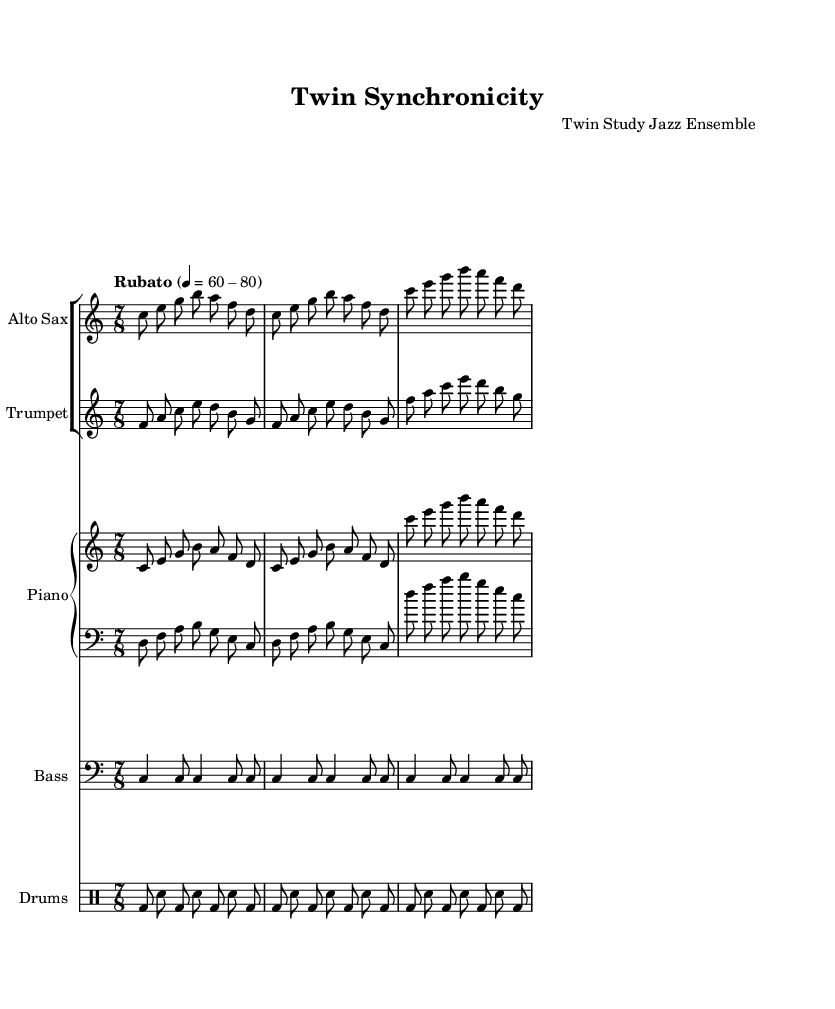What is the time signature of this music? The time signature is indicated at the beginning of the piece, where it is shown as 7/8. This indicates that there are seven beats in a measure and the eighth note gets one beat.
Answer: 7/8 What is the tempo marking of the composition? The tempo marking is found in the global section where it states "Rubato" with a range of quarter note beats of 60 to 80. "Rubato" suggests a flexible tempo, allowing for expressive performance.
Answer: Rubato 60-80 How many measures are there in the piano right-hand part? By examining the provided part for the piano right-hand, we notice that it contains three measures as defined by the repeated structure and the number of bars shown in the part.
Answer: 3 What instruments are featured in this composition? The instrumentation is listed in the score; it primarily includes the alto saxophone, trumpet, piano (with both right and left hand parts), bass, and drums. This diverse ensemble reflects a standard jazz ensemble setup.
Answer: Alto Sax, Trumpet, Piano, Bass, Drums What is the clef used for the alto saxophone part? In the score, the alto saxophone part clearly indicates the use of the treble clef, which is typically used for higher-pitched instruments. This can be confirmed by looking at the staff designation in the score.
Answer: Treble Clef How does the bass part differ in rhythm compared to the piano left hand? The bass part is structured with a repetitive quarter and eighth note rhythm pattern, while the piano left hand has a more varied rhythmic pattern with different note values throughout its measures, indicating more movement.
Answer: Repetitive vs. varied 